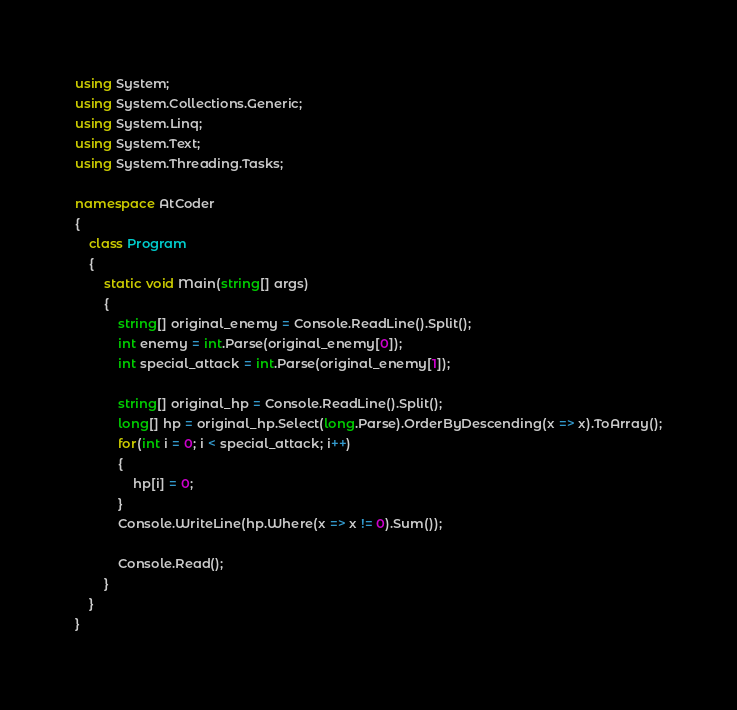<code> <loc_0><loc_0><loc_500><loc_500><_C#_>using System;
using System.Collections.Generic;
using System.Linq;
using System.Text;
using System.Threading.Tasks;

namespace AtCoder
{
    class Program
    {
        static void Main(string[] args)
        {
            string[] original_enemy = Console.ReadLine().Split();
            int enemy = int.Parse(original_enemy[0]);
            int special_attack = int.Parse(original_enemy[1]);

            string[] original_hp = Console.ReadLine().Split();
            long[] hp = original_hp.Select(long.Parse).OrderByDescending(x => x).ToArray();
            for(int i = 0; i < special_attack; i++)
            {
                hp[i] = 0;
            }
            Console.WriteLine(hp.Where(x => x != 0).Sum());

            Console.Read();
        }
    }
}</code> 